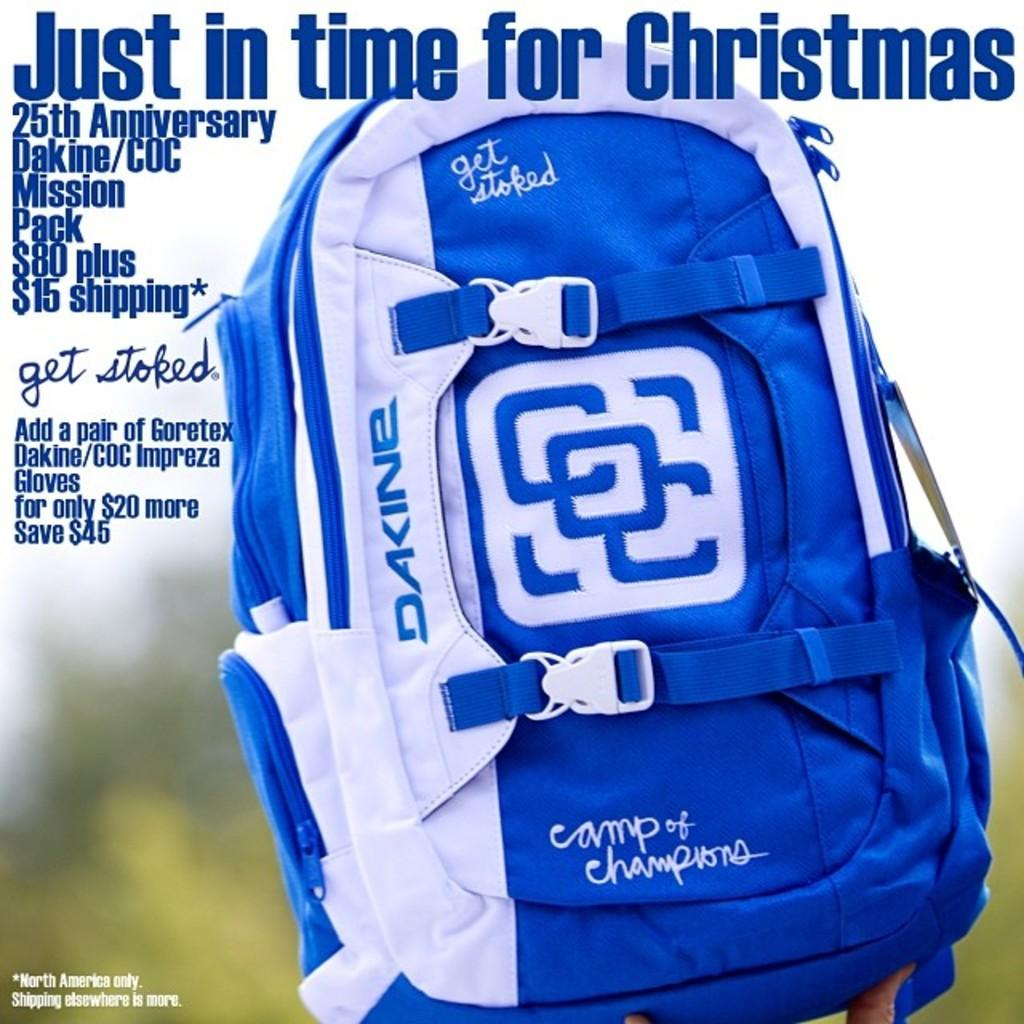Provide a one-sentence caption for the provided image. Just in time for christmas poster with a blue book bag. 